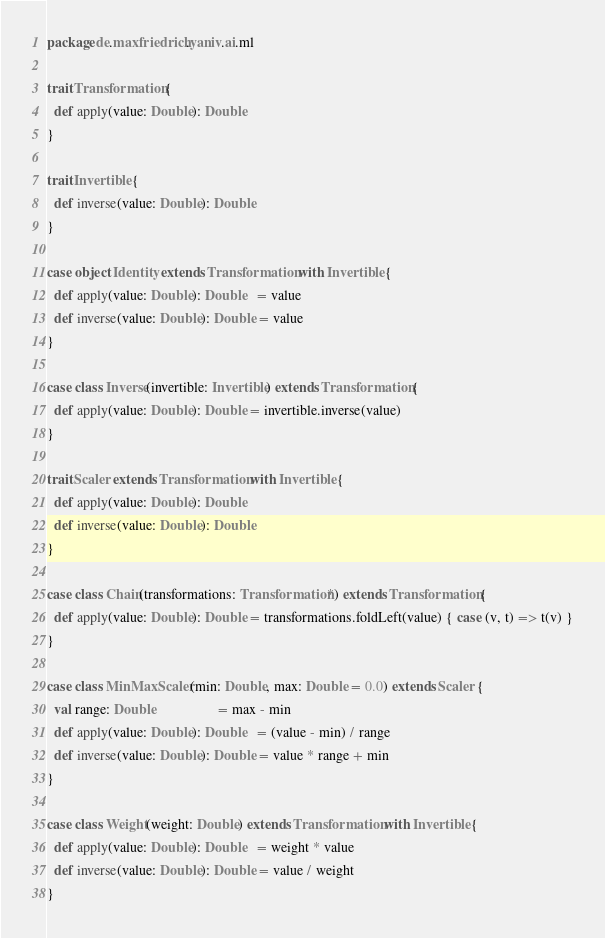Convert code to text. <code><loc_0><loc_0><loc_500><loc_500><_Scala_>package de.maxfriedrich.yaniv.ai.ml

trait Transformation {
  def apply(value: Double): Double
}

trait Invertible {
  def inverse(value: Double): Double
}

case object Identity extends Transformation with Invertible {
  def apply(value: Double): Double   = value
  def inverse(value: Double): Double = value
}

case class Inverse(invertible: Invertible) extends Transformation {
  def apply(value: Double): Double = invertible.inverse(value)
}

trait Scaler extends Transformation with Invertible {
  def apply(value: Double): Double
  def inverse(value: Double): Double
}

case class Chain(transformations: Transformation*) extends Transformation {
  def apply(value: Double): Double = transformations.foldLeft(value) { case (v, t) => t(v) }
}

case class MinMaxScaler(min: Double, max: Double = 0.0) extends Scaler {
  val range: Double                  = max - min
  def apply(value: Double): Double   = (value - min) / range
  def inverse(value: Double): Double = value * range + min
}

case class Weight(weight: Double) extends Transformation with Invertible {
  def apply(value: Double): Double   = weight * value
  def inverse(value: Double): Double = value / weight
}
</code> 